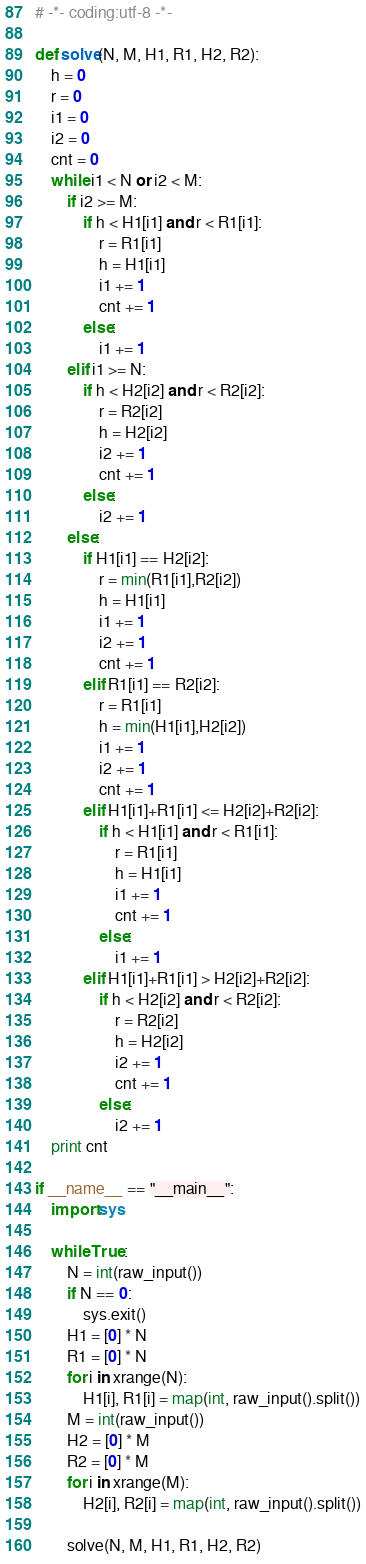Convert code to text. <code><loc_0><loc_0><loc_500><loc_500><_Python_># -*- coding:utf-8 -*-

def solve(N, M, H1, R1, H2, R2):
    h = 0
    r = 0
    i1 = 0
    i2 = 0
    cnt = 0
    while i1 < N or i2 < M:
        if i2 >= M:
            if h < H1[i1] and r < R1[i1]:
                r = R1[i1]
                h = H1[i1]
                i1 += 1
                cnt += 1
            else:
                i1 += 1
        elif i1 >= N:
            if h < H2[i2] and r < R2[i2]:
                r = R2[i2]
                h = H2[i2]
                i2 += 1
                cnt += 1
            else:
                i2 += 1
        else:
            if H1[i1] == H2[i2]:
                r = min(R1[i1],R2[i2])
                h = H1[i1]
                i1 += 1
                i2 += 1
                cnt += 1
            elif R1[i1] == R2[i2]:
                r = R1[i1]
                h = min(H1[i1],H2[i2])
                i1 += 1
                i2 += 1
                cnt += 1
            elif H1[i1]+R1[i1] <= H2[i2]+R2[i2]:
                if h < H1[i1] and r < R1[i1]:
                    r = R1[i1]
                    h = H1[i1]
                    i1 += 1
                    cnt += 1
                else:
                    i1 += 1
            elif H1[i1]+R1[i1] > H2[i2]+R2[i2]:
                if h < H2[i2] and r < R2[i2]:
                    r = R2[i2]
                    h = H2[i2]
                    i2 += 1
                    cnt += 1
                else:
                    i2 += 1
    print cnt

if __name__ == "__main__":
    import sys

    while True:
        N = int(raw_input())
        if N == 0:
            sys.exit()
        H1 = [0] * N
        R1 = [0] * N
        for i in xrange(N):
            H1[i], R1[i] = map(int, raw_input().split())
        M = int(raw_input())
        H2 = [0] * M
        R2 = [0] * M
        for i in xrange(M):
            H2[i], R2[i] = map(int, raw_input().split())

        solve(N, M, H1, R1, H2, R2)</code> 